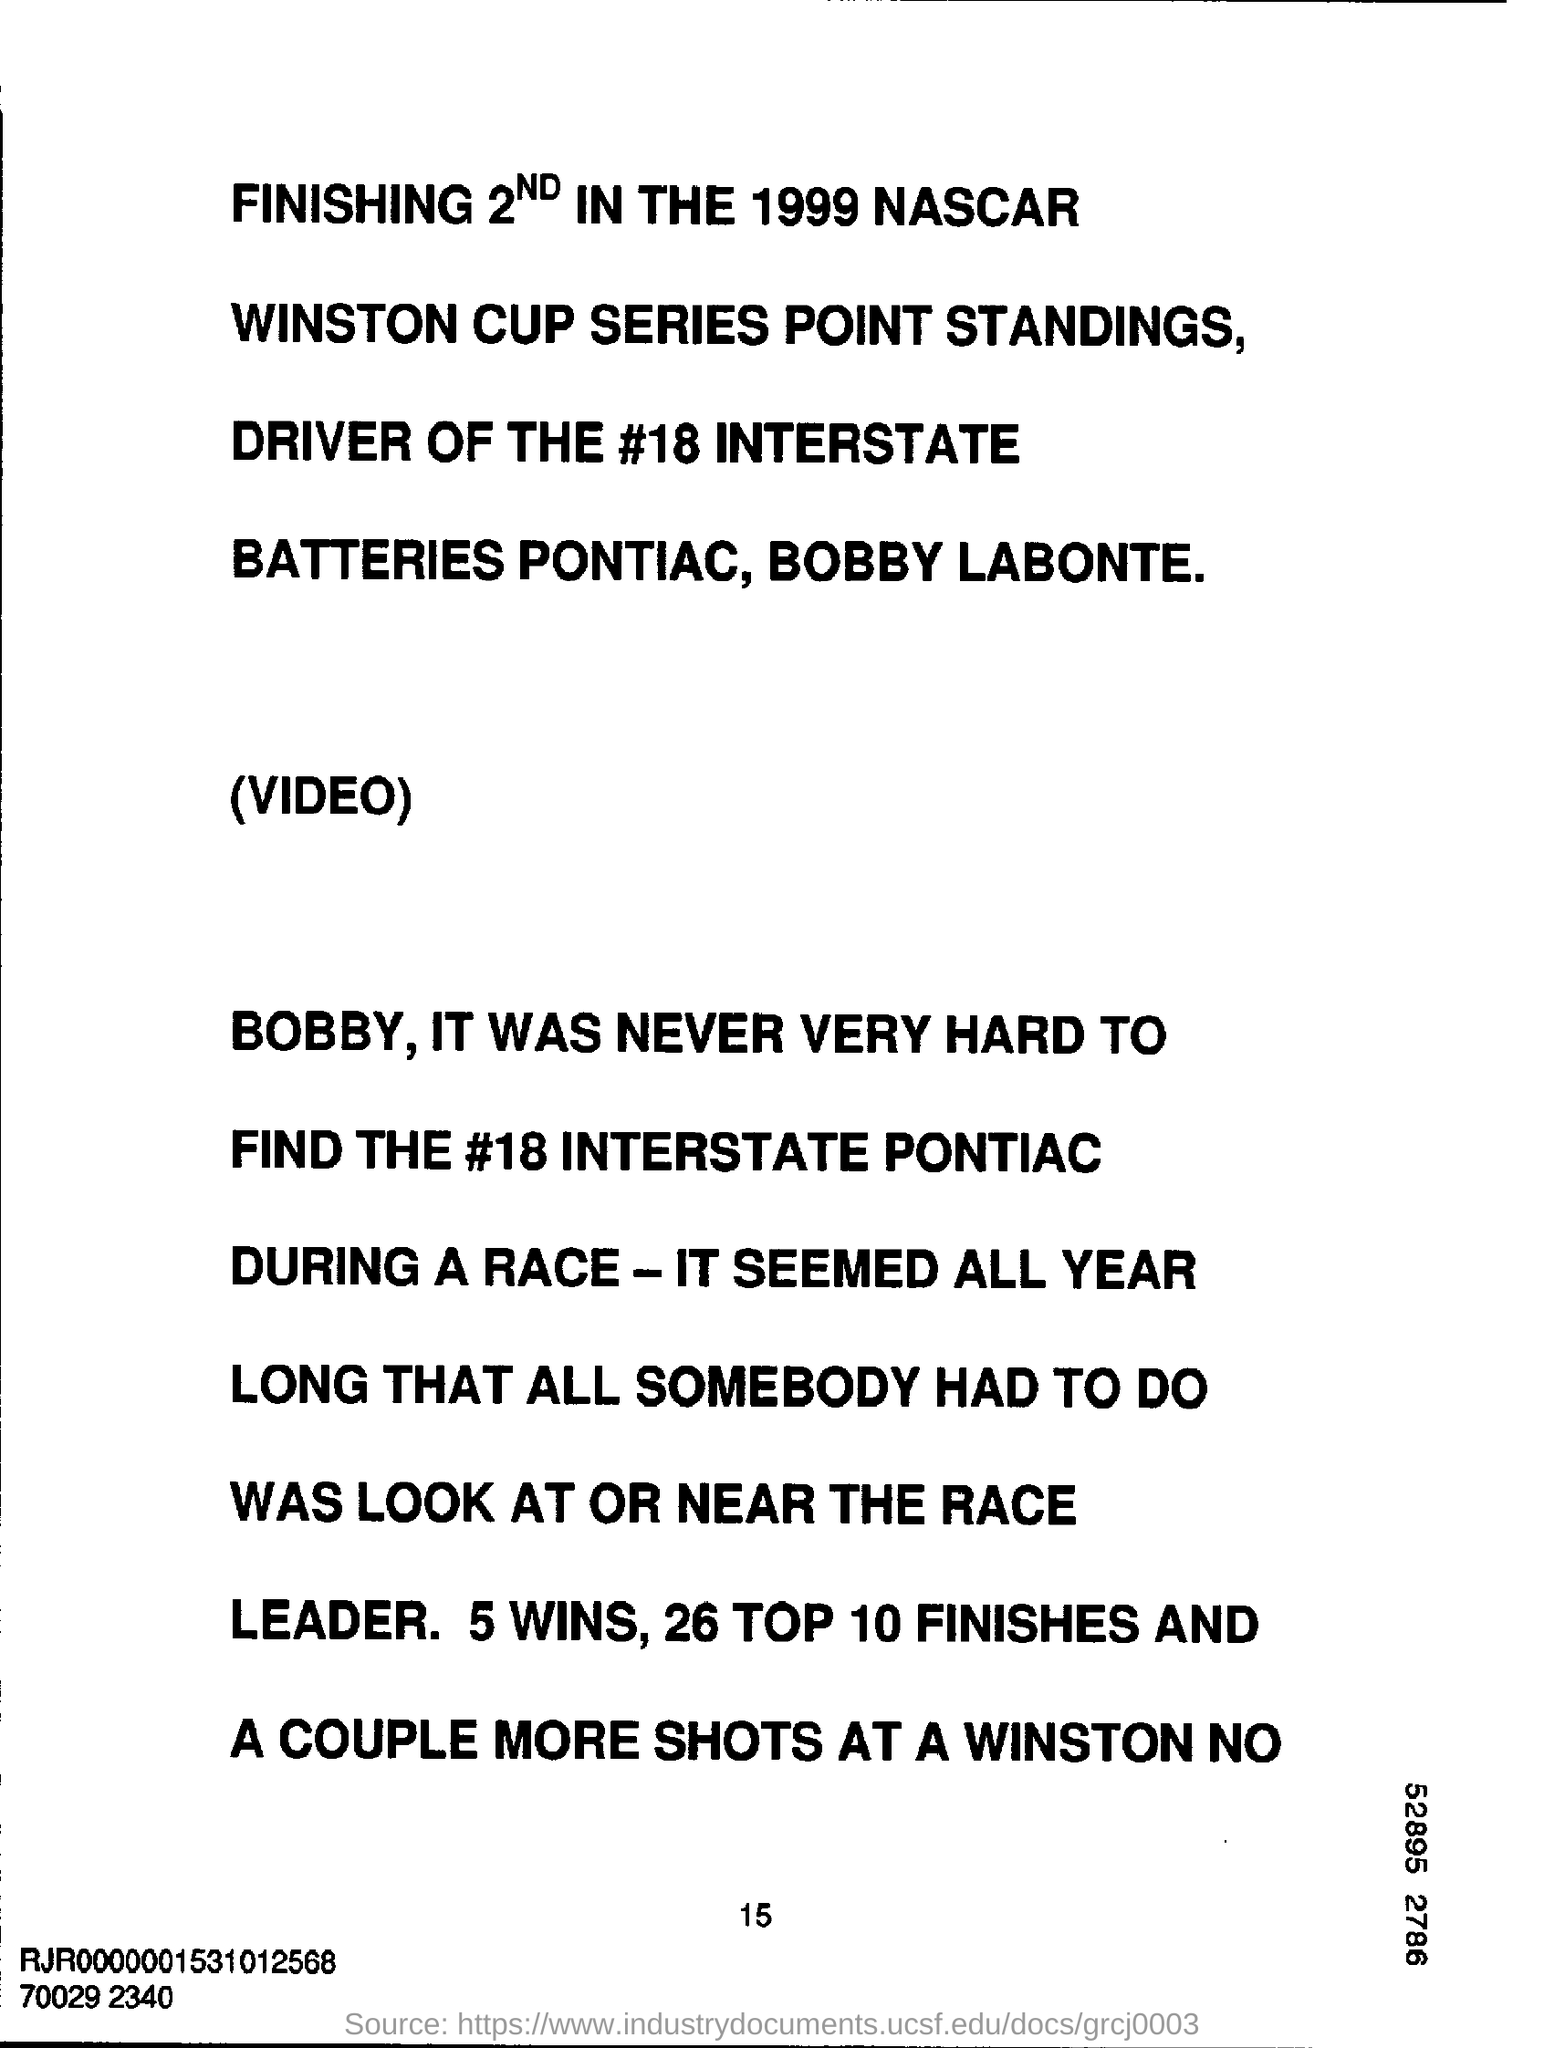What is the year mentioned?
Offer a terse response. 1999. What number does the hashtag read?
Provide a short and direct response. 18. How many wins are mentioned?
Your answer should be very brief. 5. 